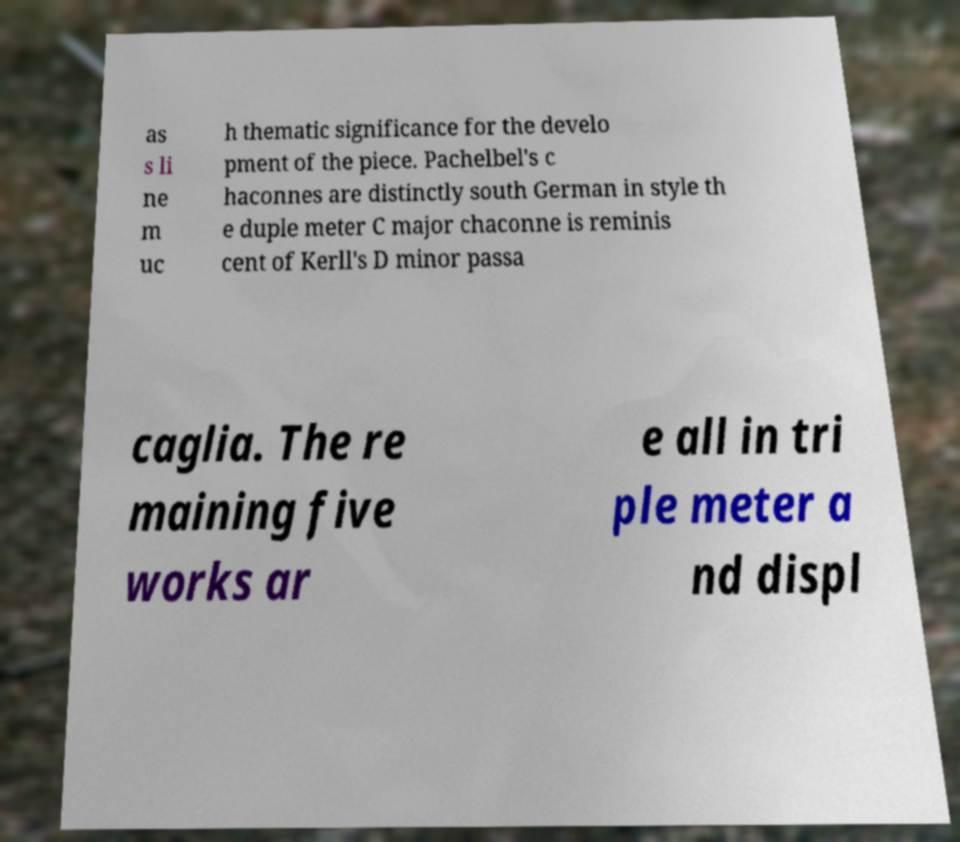Please read and relay the text visible in this image. What does it say? as s li ne m uc h thematic significance for the develo pment of the piece. Pachelbel's c haconnes are distinctly south German in style th e duple meter C major chaconne is reminis cent of Kerll's D minor passa caglia. The re maining five works ar e all in tri ple meter a nd displ 